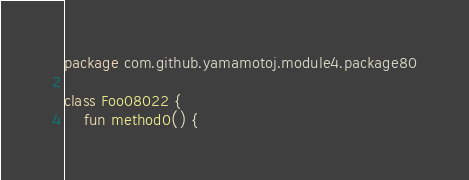<code> <loc_0><loc_0><loc_500><loc_500><_Kotlin_>package com.github.yamamotoj.module4.package80

class Foo08022 {
    fun method0() {</code> 